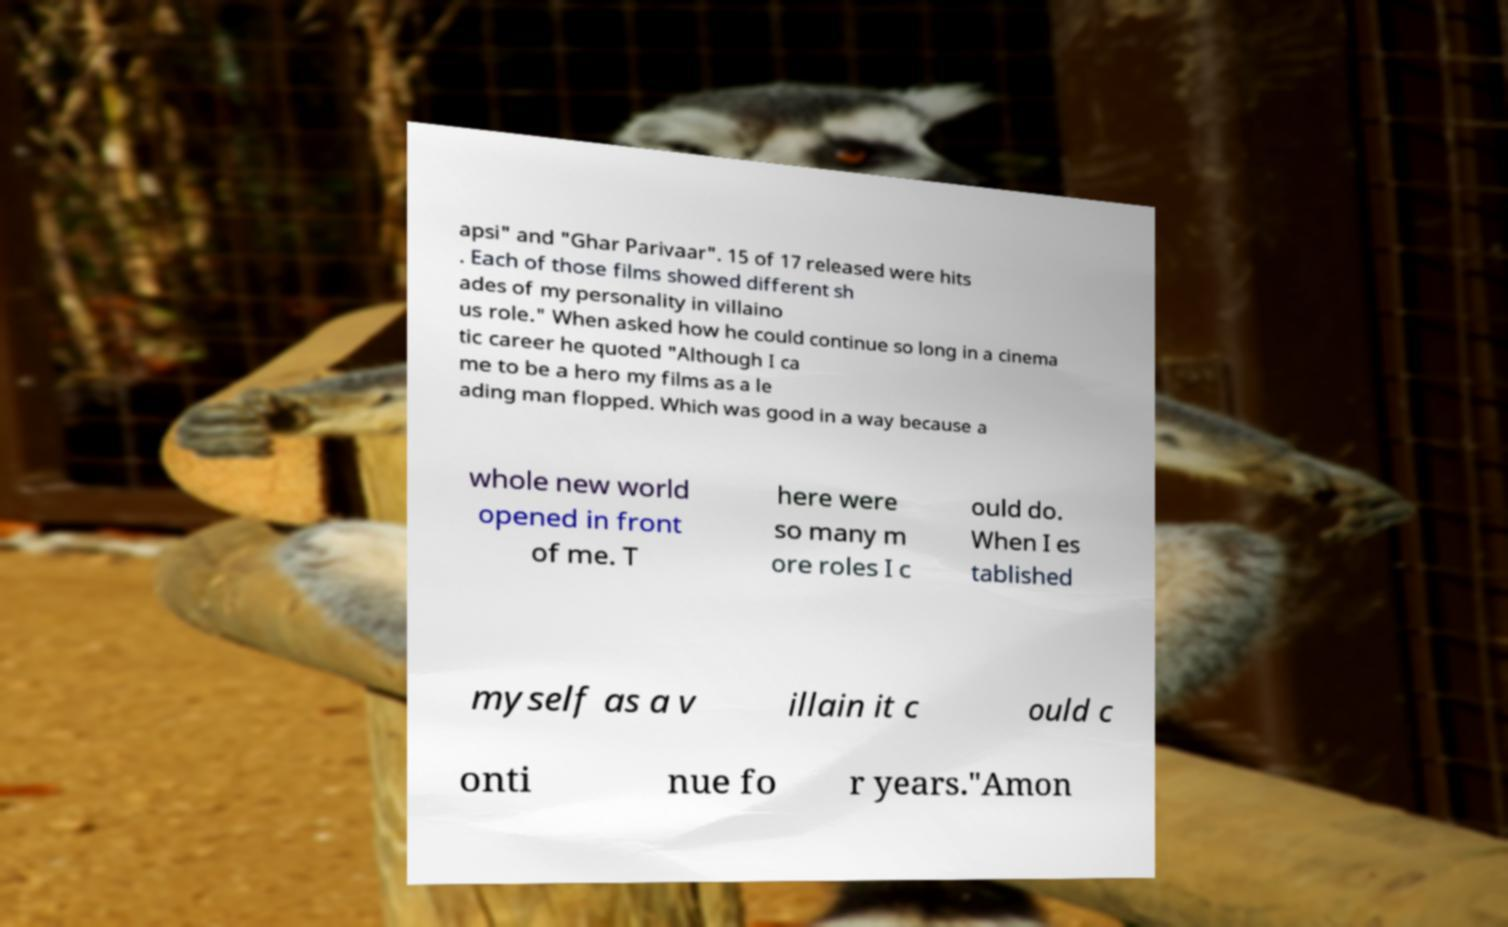For documentation purposes, I need the text within this image transcribed. Could you provide that? apsi" and "Ghar Parivaar". 15 of 17 released were hits . Each of those films showed different sh ades of my personality in villaino us role." When asked how he could continue so long in a cinema tic career he quoted "Although I ca me to be a hero my films as a le ading man flopped. Which was good in a way because a whole new world opened in front of me. T here were so many m ore roles I c ould do. When I es tablished myself as a v illain it c ould c onti nue fo r years."Amon 